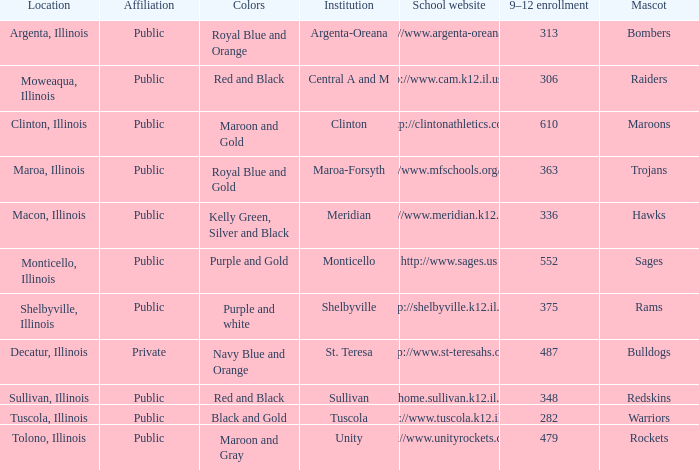What's the name of the city or town of the school that operates the http://www.mfschools.org/high/ website? Maroa-Forsyth. 